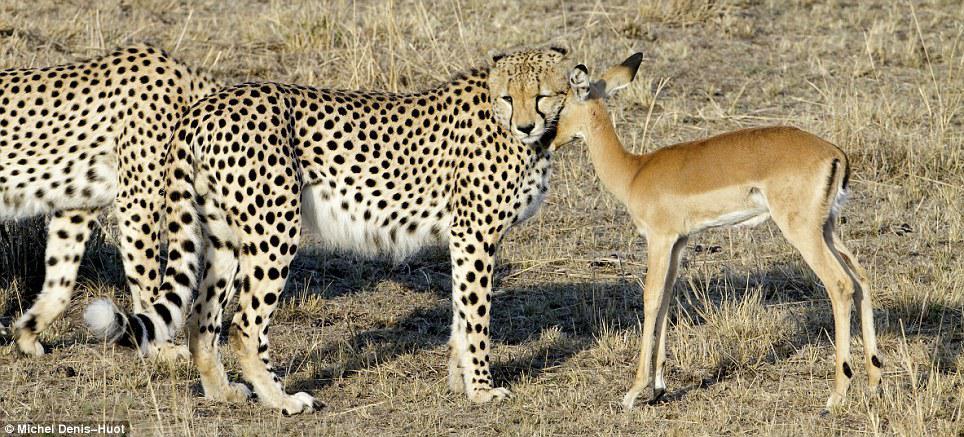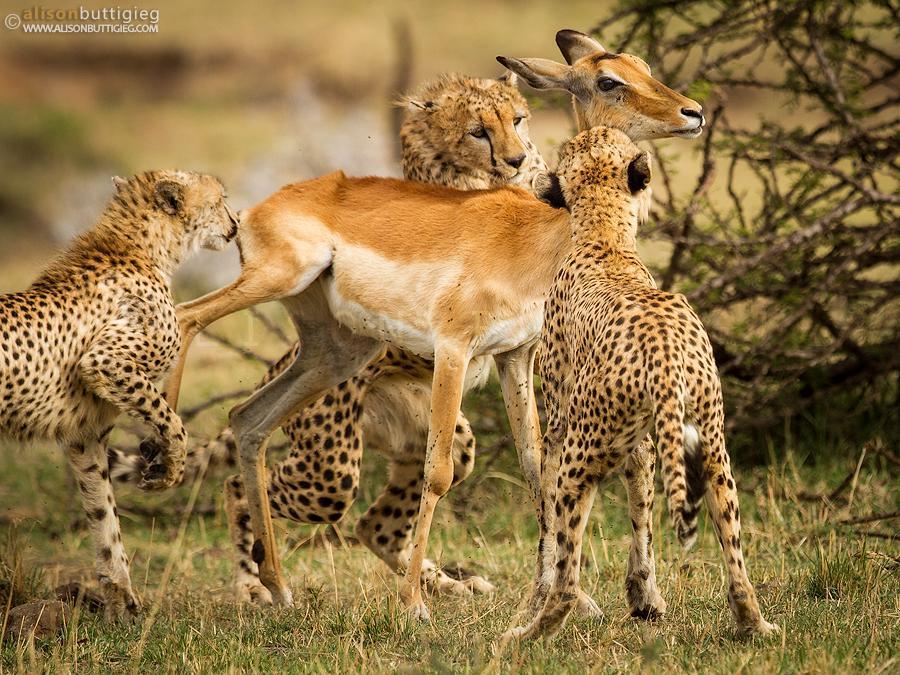The first image is the image on the left, the second image is the image on the right. Assess this claim about the two images: "In one image there is a pair of cheetahs biting an antelope on the neck.". Correct or not? Answer yes or no. No. 